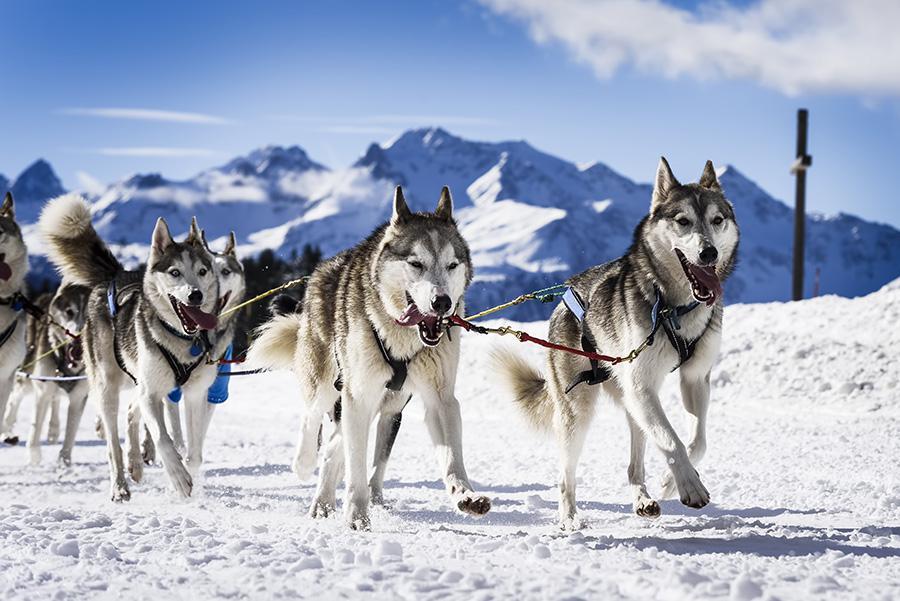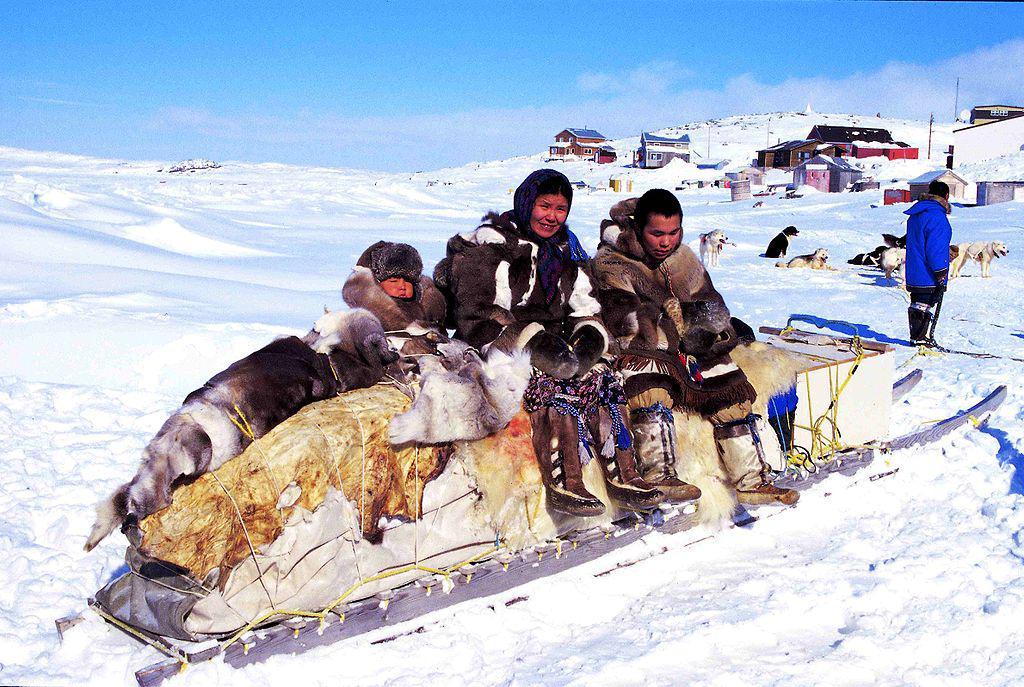The first image is the image on the left, the second image is the image on the right. Considering the images on both sides, is "In the left image, dogs are moving forward." valid? Answer yes or no. Yes. 